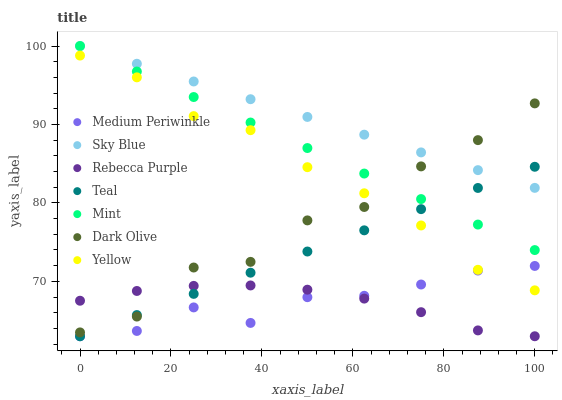Does Rebecca Purple have the minimum area under the curve?
Answer yes or no. Yes. Does Sky Blue have the maximum area under the curve?
Answer yes or no. Yes. Does Medium Periwinkle have the minimum area under the curve?
Answer yes or no. No. Does Medium Periwinkle have the maximum area under the curve?
Answer yes or no. No. Is Mint the smoothest?
Answer yes or no. Yes. Is Dark Olive the roughest?
Answer yes or no. Yes. Is Medium Periwinkle the smoothest?
Answer yes or no. No. Is Medium Periwinkle the roughest?
Answer yes or no. No. Does Medium Periwinkle have the lowest value?
Answer yes or no. Yes. Does Yellow have the lowest value?
Answer yes or no. No. Does Mint have the highest value?
Answer yes or no. Yes. Does Medium Periwinkle have the highest value?
Answer yes or no. No. Is Medium Periwinkle less than Dark Olive?
Answer yes or no. Yes. Is Dark Olive greater than Medium Periwinkle?
Answer yes or no. Yes. Does Yellow intersect Teal?
Answer yes or no. Yes. Is Yellow less than Teal?
Answer yes or no. No. Is Yellow greater than Teal?
Answer yes or no. No. Does Medium Periwinkle intersect Dark Olive?
Answer yes or no. No. 